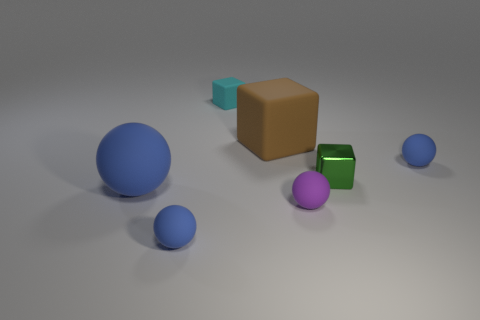How many blue spheres must be subtracted to get 1 blue spheres? 2 Subtract all cyan rubber blocks. How many blocks are left? 2 Add 2 small blue metallic cubes. How many objects exist? 9 Subtract all blue spheres. How many spheres are left? 1 Subtract 2 spheres. How many spheres are left? 2 Subtract all purple balls. How many cyan blocks are left? 1 Subtract all large metal blocks. Subtract all large cubes. How many objects are left? 6 Add 3 brown things. How many brown things are left? 4 Add 1 brown rubber things. How many brown rubber things exist? 2 Subtract 0 blue cylinders. How many objects are left? 7 